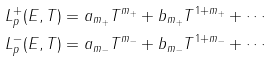<formula> <loc_0><loc_0><loc_500><loc_500>L _ { p } ^ { + } ( E , T ) & = a _ { m _ { + } } T ^ { m _ { + } } + b _ { m _ { + } } T ^ { 1 + m _ { + } } + \cdots \\ L _ { p } ^ { - } ( E , T ) & = a _ { m _ { - } } T ^ { m _ { - } } + b _ { m _ { - } } T ^ { 1 + m _ { - } } + \cdots</formula> 